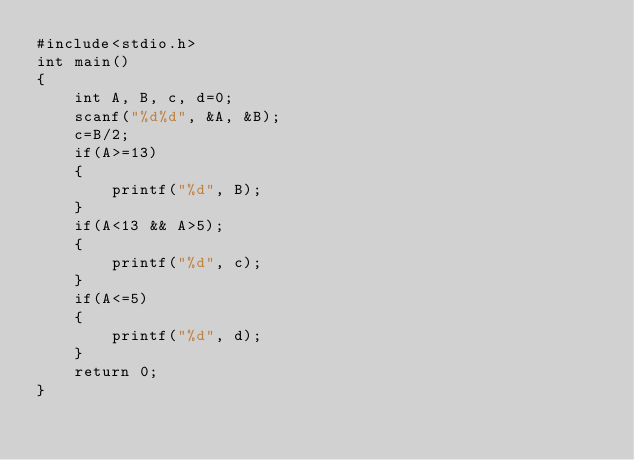<code> <loc_0><loc_0><loc_500><loc_500><_C_>#include<stdio.h>
int main()
{
    int A, B, c, d=0;
    scanf("%d%d", &A, &B);
    c=B/2;
    if(A>=13)
    {
        printf("%d", B);
    }
    if(A<13 && A>5);
    {
        printf("%d", c);
    }
    if(A<=5)
    {
        printf("%d", d);
    }
    return 0;
}

</code> 